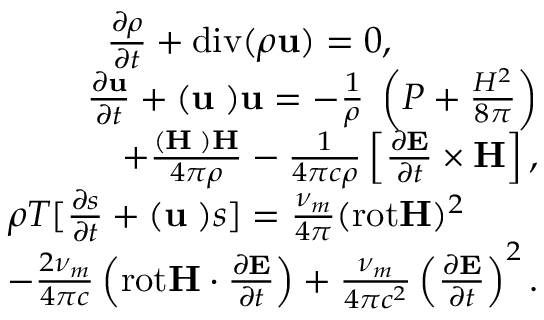<formula> <loc_0><loc_0><loc_500><loc_500>\begin{array} { r } { \frac { \partial \rho } { \partial t } + d i v ( \rho { u } ) = 0 , \quad } \\ { \frac { \partial { u } } { \partial t } + ( { u \nabla ) u } = - \frac { 1 } { \rho } { \nabla } \left ( P + \frac { H ^ { 2 } } { 8 \pi } \right ) } \\ { + \frac { ( { H \nabla ) H } } { 4 \pi \rho } - \frac { 1 } { 4 \pi c \rho } \left [ \frac { \partial { E } } { \partial t } \times { H } \right ] , } \\ { \rho T [ \frac { \partial { s } } { \partial t } + ( { u \nabla ) } s ] = \frac { \nu _ { m } } { 4 \pi } ( r o t { H } ) ^ { 2 } \quad } \\ { - \frac { 2 \nu _ { m } } { 4 \pi c } \left ( r o t { H } \cdot \frac { \partial { E } } { \partial t } \right ) + \frac { \nu _ { m } } { 4 \pi c ^ { 2 } } \left ( \frac { \partial { E } } { \partial t } \right ) ^ { 2 } . } \end{array}</formula> 